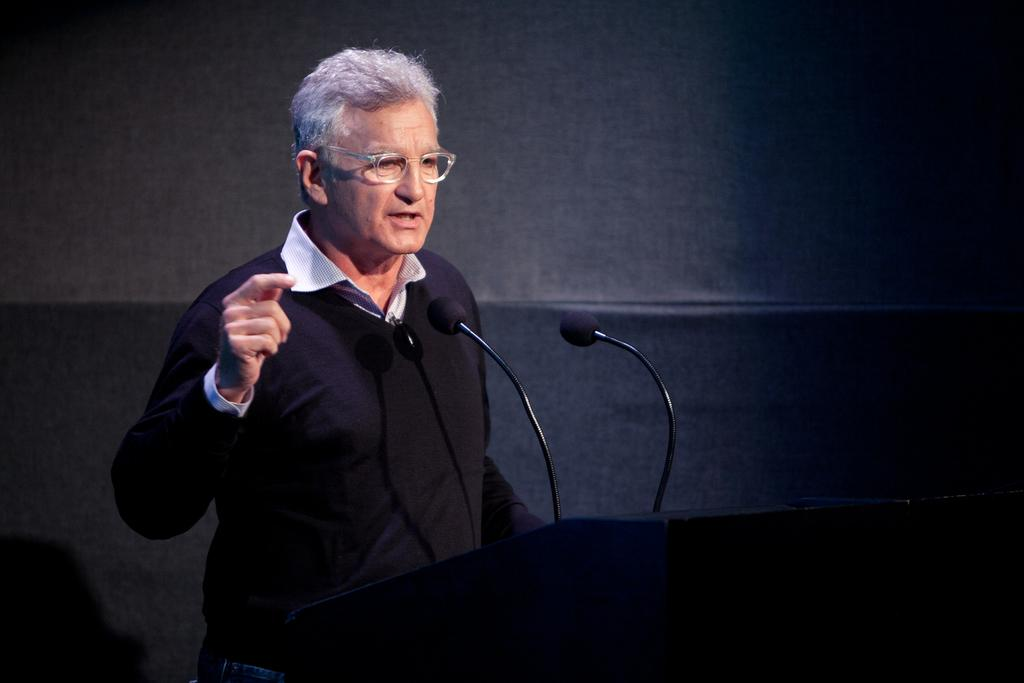Who is the main subject in the foreground of the image? There is a man in the foreground of the image. What is the man standing in front of? The man is standing in front of a podium. What can be seen on the podium? There are mics on the podium. Can you describe the background of the image? The background of the image is not clear. What type of plastic material is being used to cause a reaction in the image? There is no plastic material or reaction present in the image. 